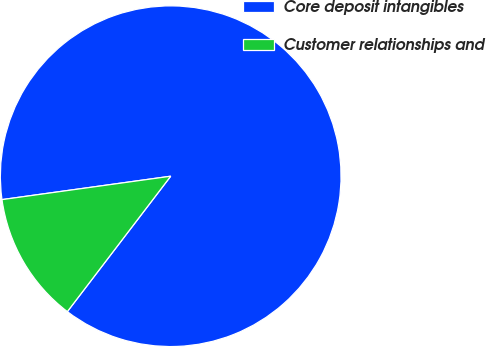Convert chart. <chart><loc_0><loc_0><loc_500><loc_500><pie_chart><fcel>Core deposit intangibles<fcel>Customer relationships and<nl><fcel>87.57%<fcel>12.43%<nl></chart> 